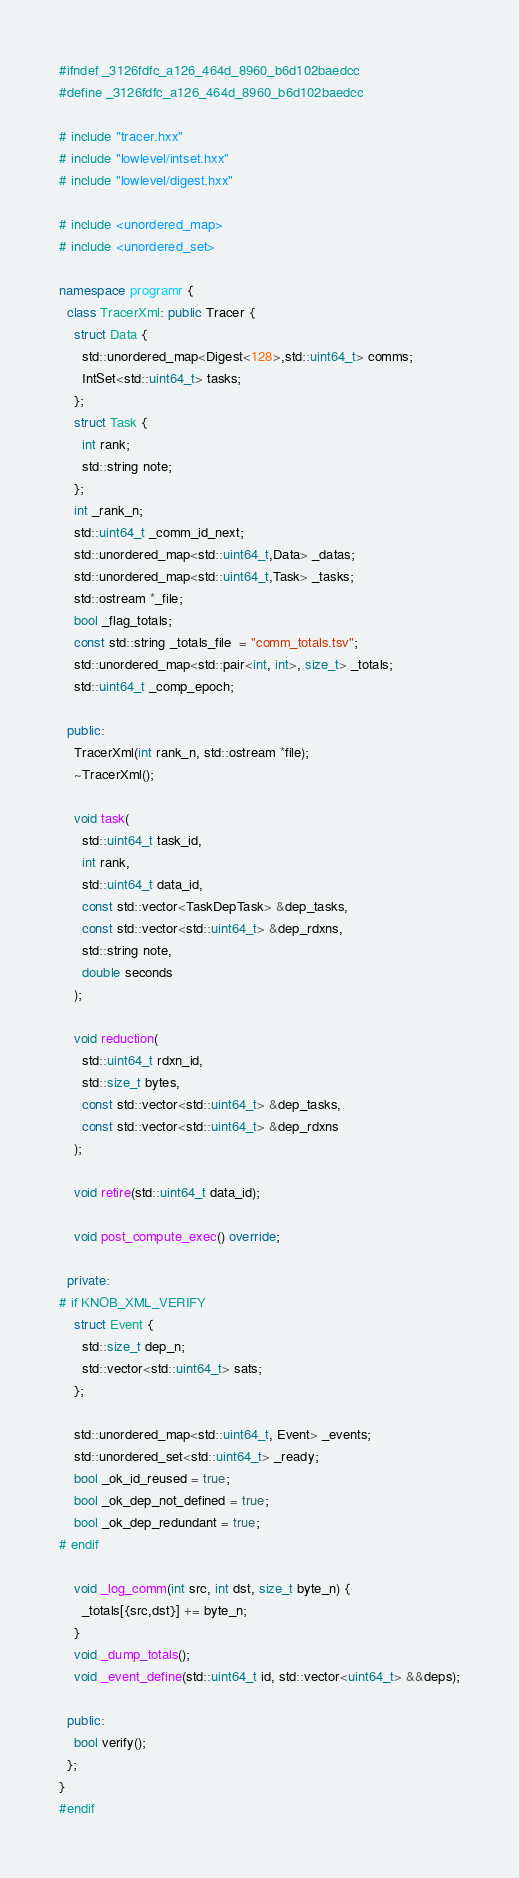Convert code to text. <code><loc_0><loc_0><loc_500><loc_500><_C++_>#ifndef _3126fdfc_a126_464d_8960_b6d102baedcc
#define _3126fdfc_a126_464d_8960_b6d102baedcc

# include "tracer.hxx"
# include "lowlevel/intset.hxx"
# include "lowlevel/digest.hxx"

# include <unordered_map>
# include <unordered_set>

namespace programr {
  class TracerXml: public Tracer {
    struct Data {
      std::unordered_map<Digest<128>,std::uint64_t> comms;
      IntSet<std::uint64_t> tasks;
    };
    struct Task {
      int rank;
      std::string note;
    };
    int _rank_n;
    std::uint64_t _comm_id_next;
    std::unordered_map<std::uint64_t,Data> _datas;
    std::unordered_map<std::uint64_t,Task> _tasks;
    std::ostream *_file;
    bool _flag_totals;
    const std::string _totals_file  = "comm_totals.tsv";
    std::unordered_map<std::pair<int, int>, size_t> _totals;
    std::uint64_t _comp_epoch;
  
  public:
    TracerXml(int rank_n, std::ostream *file);
    ~TracerXml();
    
    void task(
      std::uint64_t task_id,
      int rank,
      std::uint64_t data_id,
      const std::vector<TaskDepTask> &dep_tasks,
      const std::vector<std::uint64_t> &dep_rdxns,
      std::string note,
      double seconds
    );
    
    void reduction(
      std::uint64_t rdxn_id,
      std::size_t bytes,
      const std::vector<std::uint64_t> &dep_tasks,
      const std::vector<std::uint64_t> &dep_rdxns
    );
    
    void retire(std::uint64_t data_id);

    void post_compute_exec() override;

  private:
# if KNOB_XML_VERIFY
    struct Event {
      std::size_t dep_n;
      std::vector<std::uint64_t> sats;
    };
    
    std::unordered_map<std::uint64_t, Event> _events;
    std::unordered_set<std::uint64_t> _ready;
    bool _ok_id_reused = true;
    bool _ok_dep_not_defined = true;
    bool _ok_dep_redundant = true;
# endif    
    
    void _log_comm(int src, int dst, size_t byte_n) {
      _totals[{src,dst}] += byte_n;
    }
    void _dump_totals();
    void _event_define(std::uint64_t id, std::vector<uint64_t> &&deps);
    
  public:
    bool verify();
  };
}
#endif
</code> 